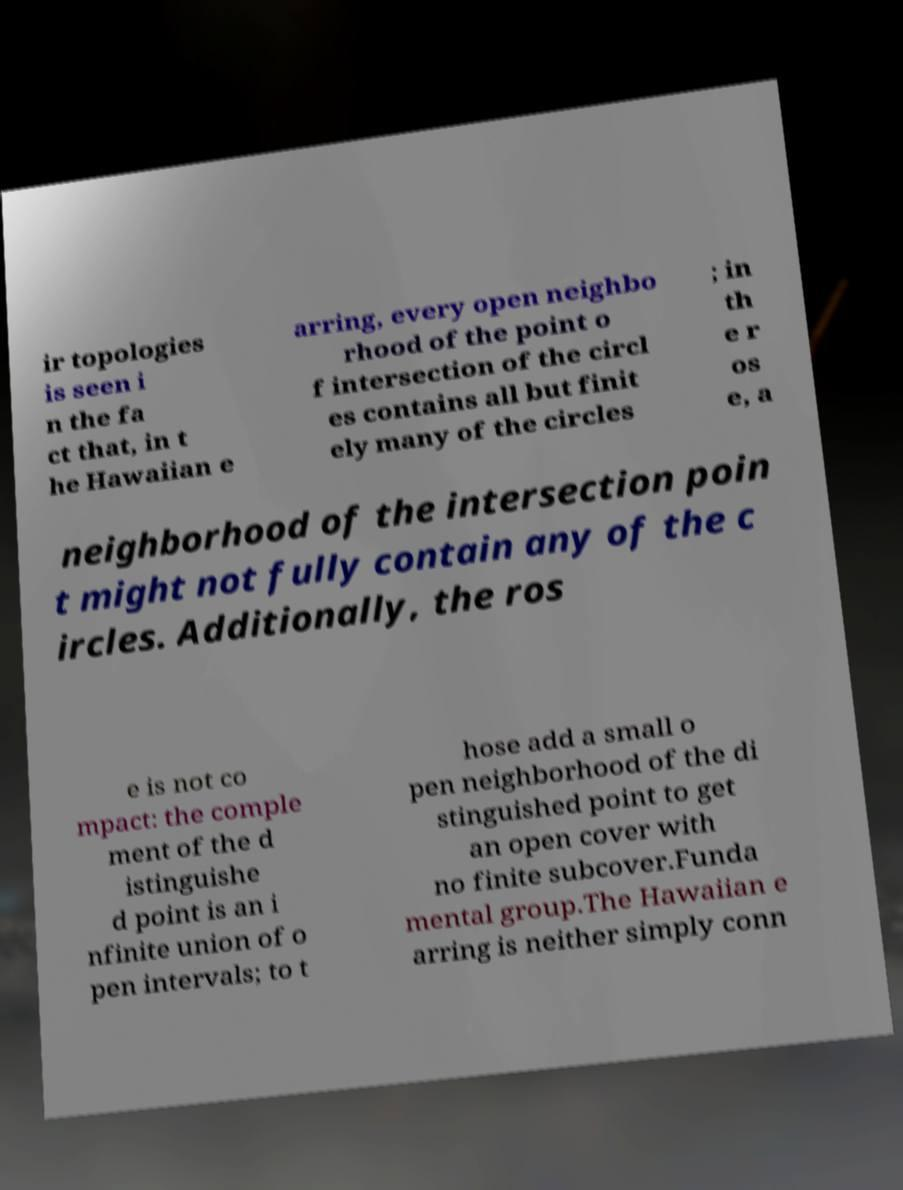Could you extract and type out the text from this image? ir topologies is seen i n the fa ct that, in t he Hawaiian e arring, every open neighbo rhood of the point o f intersection of the circl es contains all but finit ely many of the circles ; in th e r os e, a neighborhood of the intersection poin t might not fully contain any of the c ircles. Additionally, the ros e is not co mpact: the comple ment of the d istinguishe d point is an i nfinite union of o pen intervals; to t hose add a small o pen neighborhood of the di stinguished point to get an open cover with no finite subcover.Funda mental group.The Hawaiian e arring is neither simply conn 